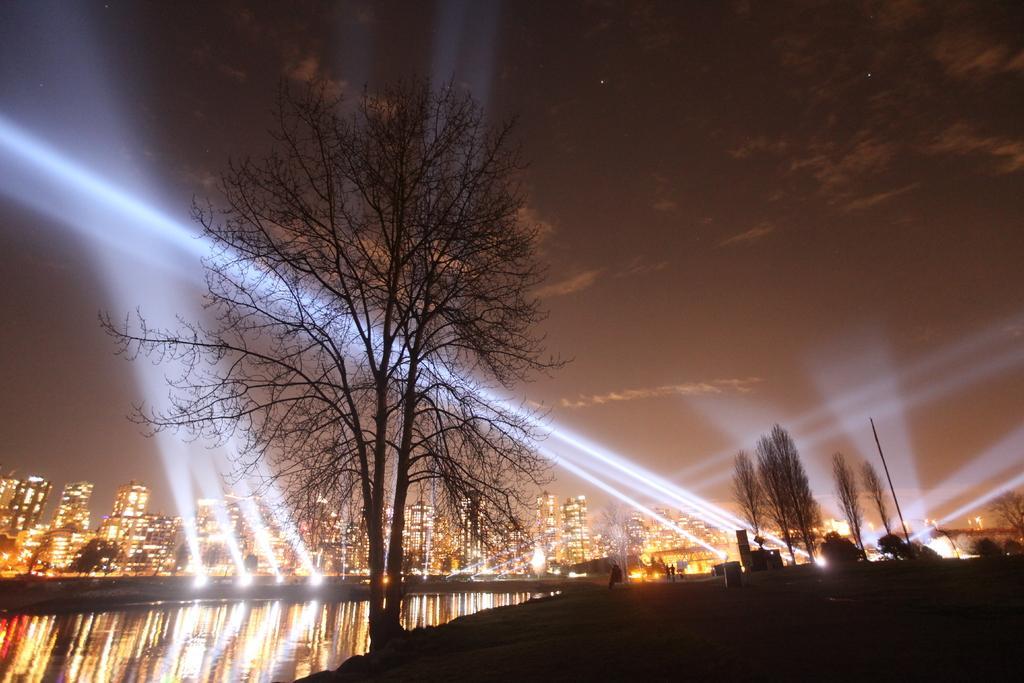Please provide a concise description of this image. This is completely outdoor picture. On the top of the picture we can see a clear sky and it is really dark. These are stars. We can able to see clouds in the sky. These are bare trees.. Here there is a lake with water. Afar we can see few buildings with lights. 